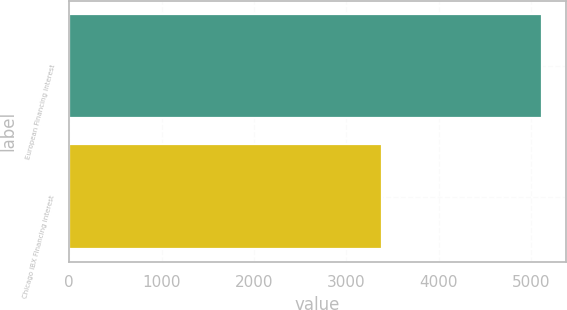Convert chart. <chart><loc_0><loc_0><loc_500><loc_500><bar_chart><fcel>European Financing interest<fcel>Chicago IBX Financing interest<nl><fcel>5117<fcel>3379<nl></chart> 